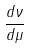<formula> <loc_0><loc_0><loc_500><loc_500>\frac { d \nu } { d \mu }</formula> 